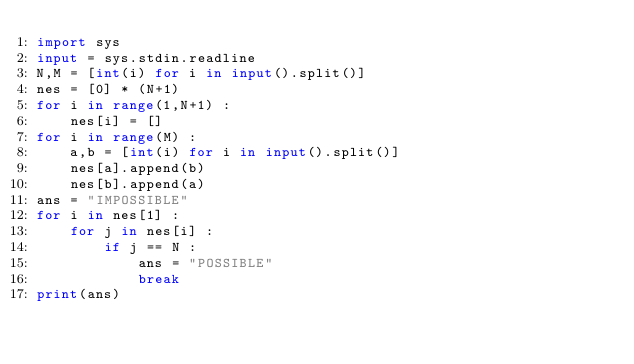Convert code to text. <code><loc_0><loc_0><loc_500><loc_500><_Python_>import sys
input = sys.stdin.readline
N,M = [int(i) for i in input().split()]
nes = [0] * (N+1)
for i in range(1,N+1) :
    nes[i] = []
for i in range(M) :
    a,b = [int(i) for i in input().split()]
    nes[a].append(b)
    nes[b].append(a)
ans = "IMPOSSIBLE"
for i in nes[1] :
    for j in nes[i] :
        if j == N :
            ans = "POSSIBLE"
            break
print(ans)</code> 